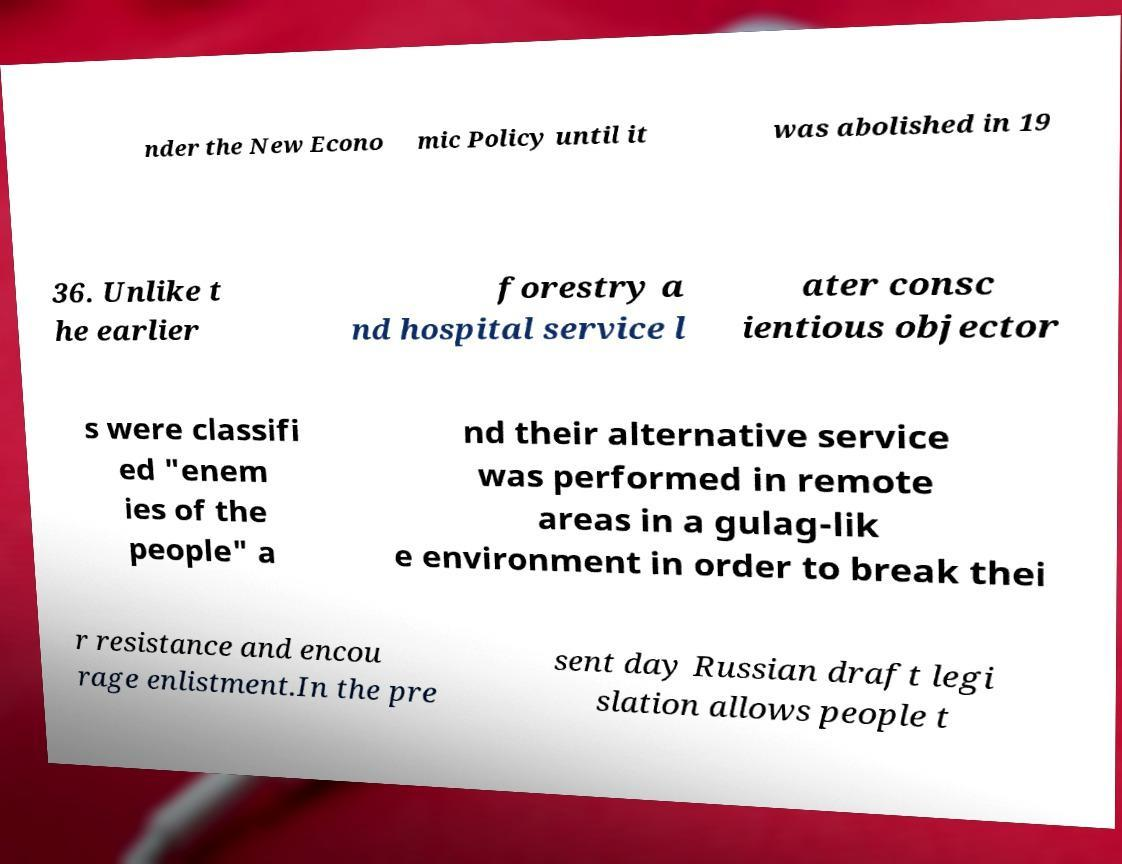Could you extract and type out the text from this image? nder the New Econo mic Policy until it was abolished in 19 36. Unlike t he earlier forestry a nd hospital service l ater consc ientious objector s were classifi ed "enem ies of the people" a nd their alternative service was performed in remote areas in a gulag-lik e environment in order to break thei r resistance and encou rage enlistment.In the pre sent day Russian draft legi slation allows people t 